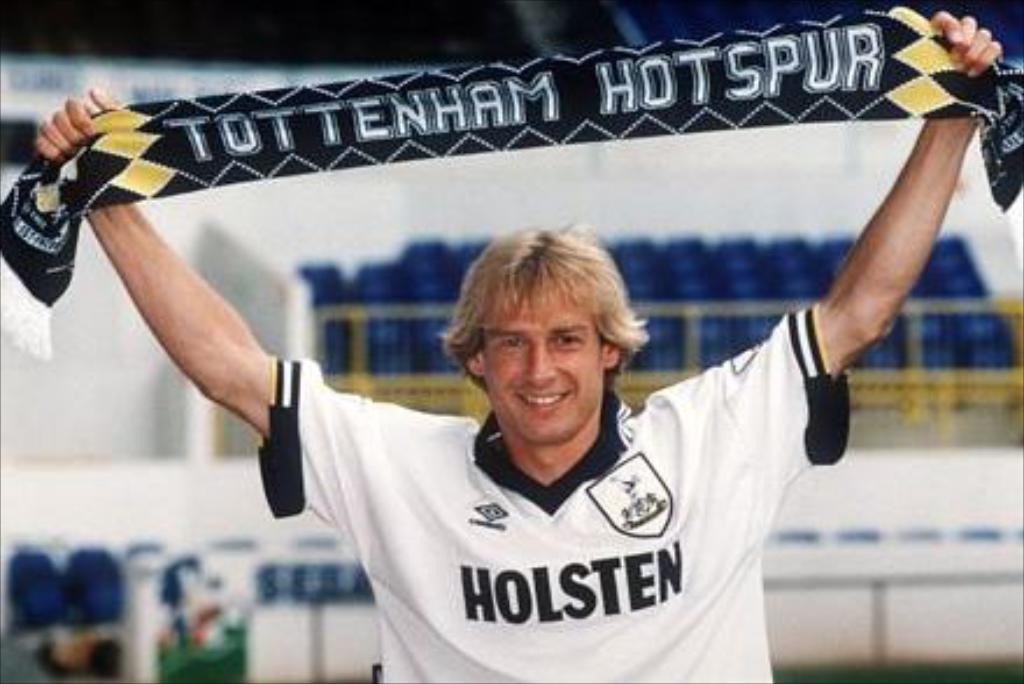Describe this image in one or two sentences. In the center of the image a person is standing and holding a cloth. In the background of the image we can see the chairs and wall are present. 